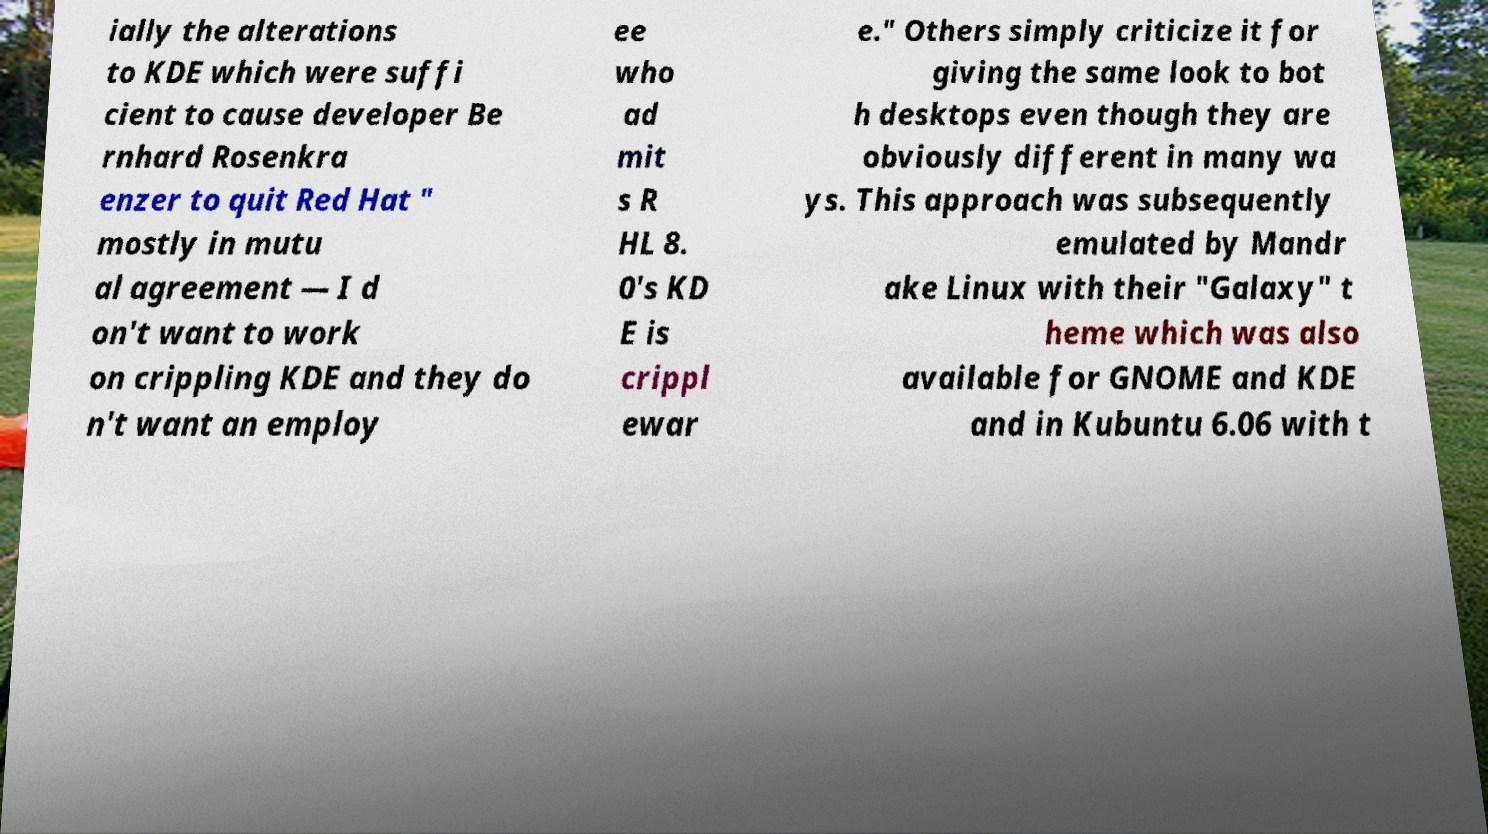Can you accurately transcribe the text from the provided image for me? ially the alterations to KDE which were suffi cient to cause developer Be rnhard Rosenkra enzer to quit Red Hat " mostly in mutu al agreement — I d on't want to work on crippling KDE and they do n't want an employ ee who ad mit s R HL 8. 0's KD E is crippl ewar e." Others simply criticize it for giving the same look to bot h desktops even though they are obviously different in many wa ys. This approach was subsequently emulated by Mandr ake Linux with their "Galaxy" t heme which was also available for GNOME and KDE and in Kubuntu 6.06 with t 